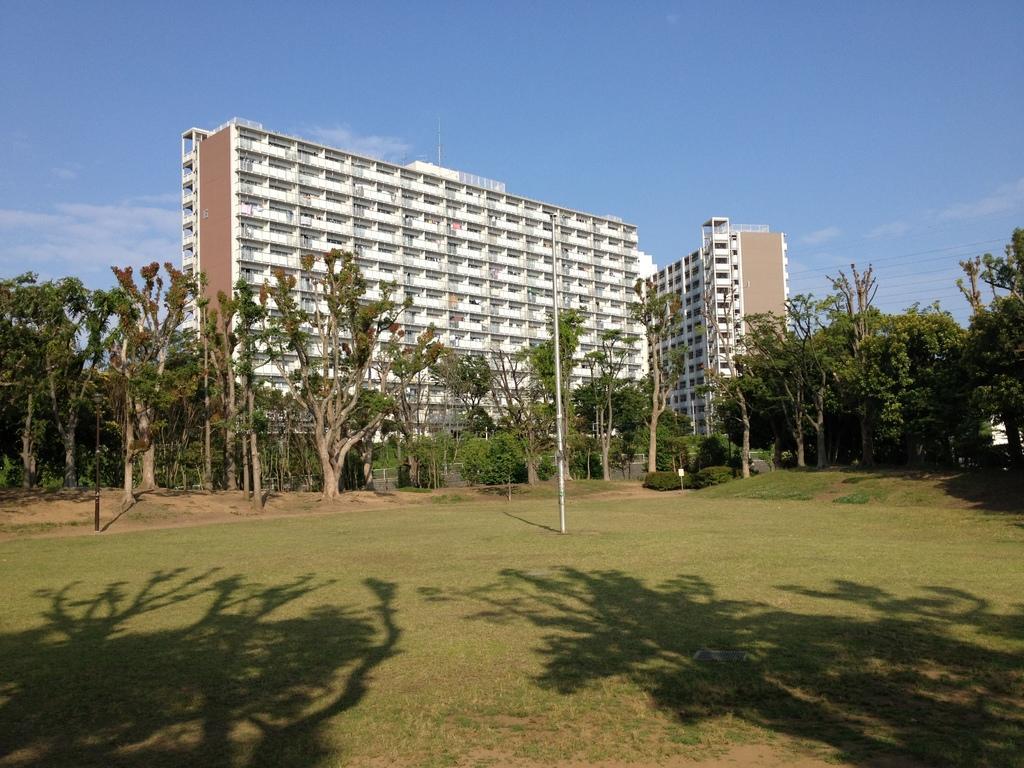How would you summarize this image in a sentence or two? In the foreground of this image, there is grassland, shadows of trees, a pole and few trees. In the background, there are buildings, sky and the cloud. 